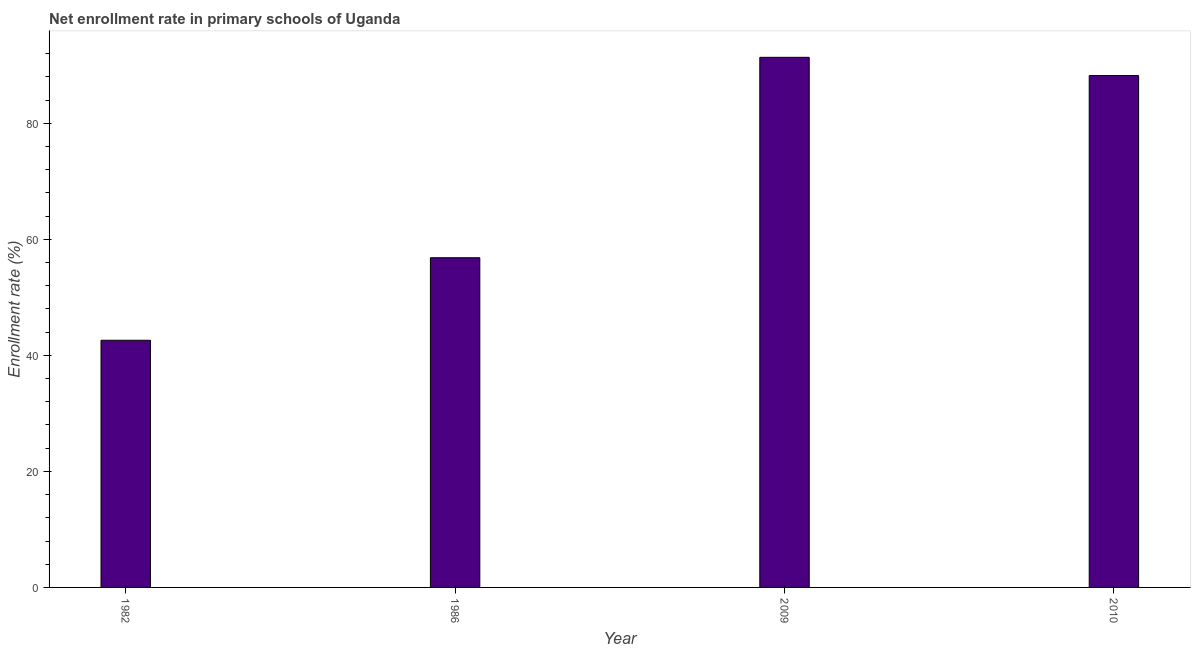What is the title of the graph?
Make the answer very short. Net enrollment rate in primary schools of Uganda. What is the label or title of the Y-axis?
Keep it short and to the point. Enrollment rate (%). What is the net enrollment rate in primary schools in 2010?
Offer a terse response. 88.22. Across all years, what is the maximum net enrollment rate in primary schools?
Offer a very short reply. 91.36. Across all years, what is the minimum net enrollment rate in primary schools?
Keep it short and to the point. 42.6. What is the sum of the net enrollment rate in primary schools?
Make the answer very short. 279. What is the difference between the net enrollment rate in primary schools in 1982 and 2010?
Make the answer very short. -45.62. What is the average net enrollment rate in primary schools per year?
Give a very brief answer. 69.75. What is the median net enrollment rate in primary schools?
Make the answer very short. 72.52. In how many years, is the net enrollment rate in primary schools greater than 68 %?
Make the answer very short. 2. What is the ratio of the net enrollment rate in primary schools in 1986 to that in 2010?
Offer a very short reply. 0.64. Is the net enrollment rate in primary schools in 1982 less than that in 2010?
Provide a succinct answer. Yes. What is the difference between the highest and the second highest net enrollment rate in primary schools?
Give a very brief answer. 3.15. What is the difference between the highest and the lowest net enrollment rate in primary schools?
Your response must be concise. 48.77. In how many years, is the net enrollment rate in primary schools greater than the average net enrollment rate in primary schools taken over all years?
Give a very brief answer. 2. How many years are there in the graph?
Give a very brief answer. 4. What is the difference between two consecutive major ticks on the Y-axis?
Make the answer very short. 20. Are the values on the major ticks of Y-axis written in scientific E-notation?
Offer a terse response. No. What is the Enrollment rate (%) in 1982?
Your answer should be very brief. 42.6. What is the Enrollment rate (%) in 1986?
Keep it short and to the point. 56.82. What is the Enrollment rate (%) in 2009?
Your response must be concise. 91.36. What is the Enrollment rate (%) in 2010?
Offer a terse response. 88.22. What is the difference between the Enrollment rate (%) in 1982 and 1986?
Ensure brevity in your answer.  -14.22. What is the difference between the Enrollment rate (%) in 1982 and 2009?
Your answer should be very brief. -48.77. What is the difference between the Enrollment rate (%) in 1982 and 2010?
Your answer should be very brief. -45.62. What is the difference between the Enrollment rate (%) in 1986 and 2009?
Offer a terse response. -34.54. What is the difference between the Enrollment rate (%) in 1986 and 2010?
Offer a very short reply. -31.4. What is the difference between the Enrollment rate (%) in 2009 and 2010?
Give a very brief answer. 3.15. What is the ratio of the Enrollment rate (%) in 1982 to that in 1986?
Keep it short and to the point. 0.75. What is the ratio of the Enrollment rate (%) in 1982 to that in 2009?
Provide a succinct answer. 0.47. What is the ratio of the Enrollment rate (%) in 1982 to that in 2010?
Keep it short and to the point. 0.48. What is the ratio of the Enrollment rate (%) in 1986 to that in 2009?
Your response must be concise. 0.62. What is the ratio of the Enrollment rate (%) in 1986 to that in 2010?
Offer a very short reply. 0.64. What is the ratio of the Enrollment rate (%) in 2009 to that in 2010?
Provide a short and direct response. 1.04. 